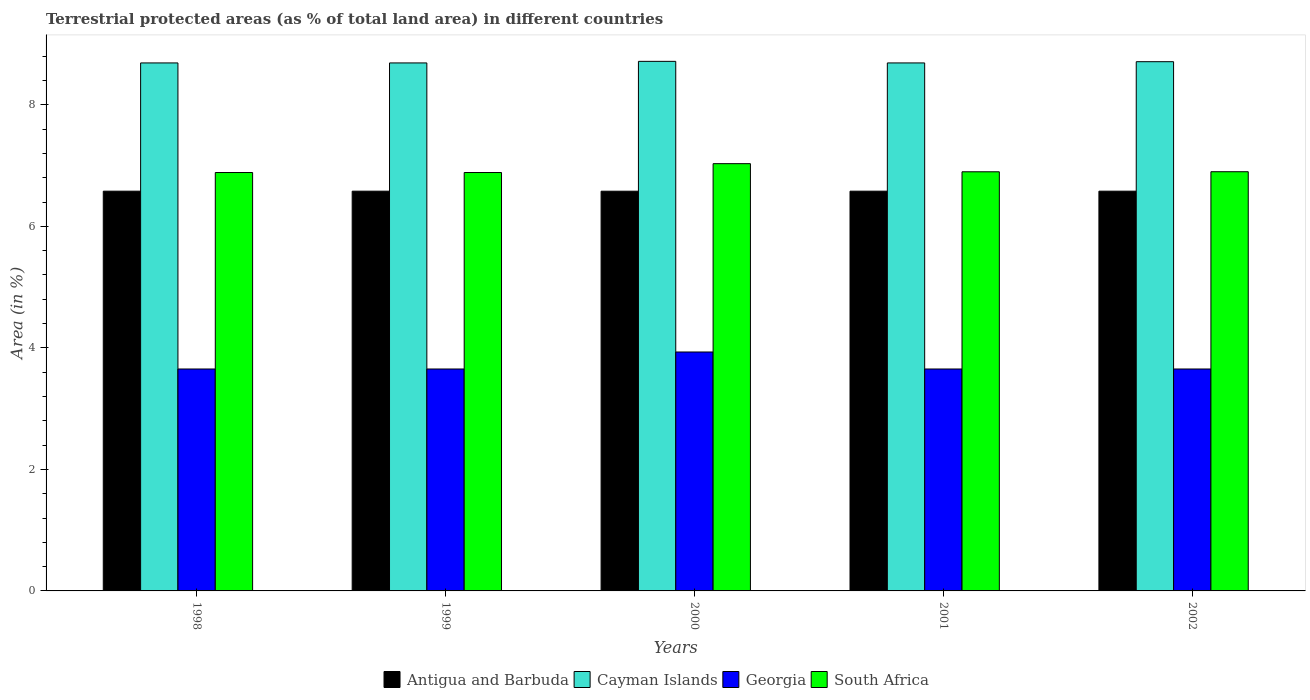How many different coloured bars are there?
Your response must be concise. 4. Are the number of bars per tick equal to the number of legend labels?
Your response must be concise. Yes. Are the number of bars on each tick of the X-axis equal?
Ensure brevity in your answer.  Yes. How many bars are there on the 3rd tick from the left?
Your answer should be compact. 4. How many bars are there on the 2nd tick from the right?
Give a very brief answer. 4. What is the label of the 3rd group of bars from the left?
Your answer should be very brief. 2000. In how many cases, is the number of bars for a given year not equal to the number of legend labels?
Your answer should be very brief. 0. What is the percentage of terrestrial protected land in South Africa in 2002?
Your response must be concise. 6.9. Across all years, what is the maximum percentage of terrestrial protected land in Georgia?
Offer a very short reply. 3.93. Across all years, what is the minimum percentage of terrestrial protected land in South Africa?
Offer a very short reply. 6.89. In which year was the percentage of terrestrial protected land in Antigua and Barbuda minimum?
Your response must be concise. 2000. What is the total percentage of terrestrial protected land in Antigua and Barbuda in the graph?
Provide a short and direct response. 32.9. What is the difference between the percentage of terrestrial protected land in Antigua and Barbuda in 1998 and that in 2002?
Provide a short and direct response. 0. What is the difference between the percentage of terrestrial protected land in Cayman Islands in 1998 and the percentage of terrestrial protected land in Georgia in 2001?
Your response must be concise. 5.04. What is the average percentage of terrestrial protected land in South Africa per year?
Ensure brevity in your answer.  6.92. In the year 2001, what is the difference between the percentage of terrestrial protected land in Antigua and Barbuda and percentage of terrestrial protected land in Georgia?
Your response must be concise. 2.93. In how many years, is the percentage of terrestrial protected land in Cayman Islands greater than 4 %?
Make the answer very short. 5. What is the ratio of the percentage of terrestrial protected land in South Africa in 2001 to that in 2002?
Your answer should be very brief. 1. Is the percentage of terrestrial protected land in South Africa in 1999 less than that in 2001?
Offer a very short reply. Yes. What is the difference between the highest and the second highest percentage of terrestrial protected land in Cayman Islands?
Make the answer very short. 0.01. What is the difference between the highest and the lowest percentage of terrestrial protected land in South Africa?
Make the answer very short. 0.15. In how many years, is the percentage of terrestrial protected land in Georgia greater than the average percentage of terrestrial protected land in Georgia taken over all years?
Keep it short and to the point. 1. Is the sum of the percentage of terrestrial protected land in Antigua and Barbuda in 1998 and 2000 greater than the maximum percentage of terrestrial protected land in Cayman Islands across all years?
Give a very brief answer. Yes. Is it the case that in every year, the sum of the percentage of terrestrial protected land in Cayman Islands and percentage of terrestrial protected land in South Africa is greater than the sum of percentage of terrestrial protected land in Antigua and Barbuda and percentage of terrestrial protected land in Georgia?
Provide a short and direct response. Yes. What does the 1st bar from the left in 1999 represents?
Make the answer very short. Antigua and Barbuda. What does the 1st bar from the right in 2000 represents?
Provide a short and direct response. South Africa. Is it the case that in every year, the sum of the percentage of terrestrial protected land in Georgia and percentage of terrestrial protected land in Antigua and Barbuda is greater than the percentage of terrestrial protected land in South Africa?
Your answer should be very brief. Yes. Are all the bars in the graph horizontal?
Ensure brevity in your answer.  No. How many years are there in the graph?
Provide a short and direct response. 5. What is the difference between two consecutive major ticks on the Y-axis?
Keep it short and to the point. 2. Are the values on the major ticks of Y-axis written in scientific E-notation?
Provide a short and direct response. No. How many legend labels are there?
Give a very brief answer. 4. What is the title of the graph?
Offer a very short reply. Terrestrial protected areas (as % of total land area) in different countries. Does "New Caledonia" appear as one of the legend labels in the graph?
Give a very brief answer. No. What is the label or title of the Y-axis?
Offer a very short reply. Area (in %). What is the Area (in %) in Antigua and Barbuda in 1998?
Offer a terse response. 6.58. What is the Area (in %) of Cayman Islands in 1998?
Keep it short and to the point. 8.69. What is the Area (in %) in Georgia in 1998?
Keep it short and to the point. 3.65. What is the Area (in %) in South Africa in 1998?
Your answer should be compact. 6.89. What is the Area (in %) in Antigua and Barbuda in 1999?
Your answer should be very brief. 6.58. What is the Area (in %) of Cayman Islands in 1999?
Provide a succinct answer. 8.69. What is the Area (in %) in Georgia in 1999?
Give a very brief answer. 3.65. What is the Area (in %) of South Africa in 1999?
Offer a terse response. 6.89. What is the Area (in %) of Antigua and Barbuda in 2000?
Provide a short and direct response. 6.58. What is the Area (in %) of Cayman Islands in 2000?
Ensure brevity in your answer.  8.72. What is the Area (in %) in Georgia in 2000?
Make the answer very short. 3.93. What is the Area (in %) of South Africa in 2000?
Your response must be concise. 7.03. What is the Area (in %) in Antigua and Barbuda in 2001?
Provide a succinct answer. 6.58. What is the Area (in %) of Cayman Islands in 2001?
Keep it short and to the point. 8.69. What is the Area (in %) of Georgia in 2001?
Keep it short and to the point. 3.65. What is the Area (in %) in South Africa in 2001?
Keep it short and to the point. 6.9. What is the Area (in %) in Antigua and Barbuda in 2002?
Keep it short and to the point. 6.58. What is the Area (in %) in Cayman Islands in 2002?
Your answer should be very brief. 8.71. What is the Area (in %) of Georgia in 2002?
Your response must be concise. 3.65. What is the Area (in %) in South Africa in 2002?
Your response must be concise. 6.9. Across all years, what is the maximum Area (in %) in Antigua and Barbuda?
Keep it short and to the point. 6.58. Across all years, what is the maximum Area (in %) in Cayman Islands?
Give a very brief answer. 8.72. Across all years, what is the maximum Area (in %) of Georgia?
Your response must be concise. 3.93. Across all years, what is the maximum Area (in %) in South Africa?
Your answer should be very brief. 7.03. Across all years, what is the minimum Area (in %) of Antigua and Barbuda?
Your answer should be compact. 6.58. Across all years, what is the minimum Area (in %) in Cayman Islands?
Offer a terse response. 8.69. Across all years, what is the minimum Area (in %) of Georgia?
Provide a short and direct response. 3.65. Across all years, what is the minimum Area (in %) of South Africa?
Give a very brief answer. 6.89. What is the total Area (in %) of Antigua and Barbuda in the graph?
Give a very brief answer. 32.9. What is the total Area (in %) in Cayman Islands in the graph?
Give a very brief answer. 43.5. What is the total Area (in %) in Georgia in the graph?
Offer a very short reply. 18.54. What is the total Area (in %) in South Africa in the graph?
Give a very brief answer. 34.6. What is the difference between the Area (in %) of Antigua and Barbuda in 1998 and that in 1999?
Offer a terse response. 0. What is the difference between the Area (in %) in Georgia in 1998 and that in 1999?
Provide a short and direct response. 0. What is the difference between the Area (in %) of Cayman Islands in 1998 and that in 2000?
Your answer should be compact. -0.03. What is the difference between the Area (in %) of Georgia in 1998 and that in 2000?
Keep it short and to the point. -0.28. What is the difference between the Area (in %) in South Africa in 1998 and that in 2000?
Make the answer very short. -0.15. What is the difference between the Area (in %) of Antigua and Barbuda in 1998 and that in 2001?
Offer a terse response. 0. What is the difference between the Area (in %) in Georgia in 1998 and that in 2001?
Provide a succinct answer. 0. What is the difference between the Area (in %) of South Africa in 1998 and that in 2001?
Make the answer very short. -0.01. What is the difference between the Area (in %) of Cayman Islands in 1998 and that in 2002?
Offer a terse response. -0.02. What is the difference between the Area (in %) of Georgia in 1998 and that in 2002?
Ensure brevity in your answer.  0. What is the difference between the Area (in %) in South Africa in 1998 and that in 2002?
Offer a terse response. -0.01. What is the difference between the Area (in %) in Antigua and Barbuda in 1999 and that in 2000?
Your answer should be compact. 0. What is the difference between the Area (in %) of Cayman Islands in 1999 and that in 2000?
Give a very brief answer. -0.03. What is the difference between the Area (in %) of Georgia in 1999 and that in 2000?
Ensure brevity in your answer.  -0.28. What is the difference between the Area (in %) of South Africa in 1999 and that in 2000?
Offer a very short reply. -0.15. What is the difference between the Area (in %) of Antigua and Barbuda in 1999 and that in 2001?
Ensure brevity in your answer.  0. What is the difference between the Area (in %) in Georgia in 1999 and that in 2001?
Your answer should be compact. 0. What is the difference between the Area (in %) of South Africa in 1999 and that in 2001?
Ensure brevity in your answer.  -0.01. What is the difference between the Area (in %) in Cayman Islands in 1999 and that in 2002?
Offer a very short reply. -0.02. What is the difference between the Area (in %) in South Africa in 1999 and that in 2002?
Offer a terse response. -0.01. What is the difference between the Area (in %) in Antigua and Barbuda in 2000 and that in 2001?
Ensure brevity in your answer.  -0. What is the difference between the Area (in %) in Cayman Islands in 2000 and that in 2001?
Provide a succinct answer. 0.03. What is the difference between the Area (in %) in Georgia in 2000 and that in 2001?
Offer a very short reply. 0.28. What is the difference between the Area (in %) in South Africa in 2000 and that in 2001?
Give a very brief answer. 0.13. What is the difference between the Area (in %) in Antigua and Barbuda in 2000 and that in 2002?
Keep it short and to the point. -0. What is the difference between the Area (in %) in Cayman Islands in 2000 and that in 2002?
Provide a succinct answer. 0.01. What is the difference between the Area (in %) in Georgia in 2000 and that in 2002?
Offer a very short reply. 0.28. What is the difference between the Area (in %) in South Africa in 2000 and that in 2002?
Ensure brevity in your answer.  0.13. What is the difference between the Area (in %) of Cayman Islands in 2001 and that in 2002?
Your answer should be compact. -0.02. What is the difference between the Area (in %) in Georgia in 2001 and that in 2002?
Offer a very short reply. 0. What is the difference between the Area (in %) of South Africa in 2001 and that in 2002?
Your answer should be compact. -0. What is the difference between the Area (in %) in Antigua and Barbuda in 1998 and the Area (in %) in Cayman Islands in 1999?
Your answer should be compact. -2.11. What is the difference between the Area (in %) in Antigua and Barbuda in 1998 and the Area (in %) in Georgia in 1999?
Provide a short and direct response. 2.93. What is the difference between the Area (in %) of Antigua and Barbuda in 1998 and the Area (in %) of South Africa in 1999?
Ensure brevity in your answer.  -0.31. What is the difference between the Area (in %) of Cayman Islands in 1998 and the Area (in %) of Georgia in 1999?
Ensure brevity in your answer.  5.04. What is the difference between the Area (in %) in Cayman Islands in 1998 and the Area (in %) in South Africa in 1999?
Your answer should be compact. 1.8. What is the difference between the Area (in %) in Georgia in 1998 and the Area (in %) in South Africa in 1999?
Your response must be concise. -3.23. What is the difference between the Area (in %) in Antigua and Barbuda in 1998 and the Area (in %) in Cayman Islands in 2000?
Your answer should be compact. -2.14. What is the difference between the Area (in %) in Antigua and Barbuda in 1998 and the Area (in %) in Georgia in 2000?
Offer a terse response. 2.65. What is the difference between the Area (in %) in Antigua and Barbuda in 1998 and the Area (in %) in South Africa in 2000?
Your response must be concise. -0.45. What is the difference between the Area (in %) in Cayman Islands in 1998 and the Area (in %) in Georgia in 2000?
Your response must be concise. 4.76. What is the difference between the Area (in %) of Cayman Islands in 1998 and the Area (in %) of South Africa in 2000?
Provide a short and direct response. 1.66. What is the difference between the Area (in %) in Georgia in 1998 and the Area (in %) in South Africa in 2000?
Provide a succinct answer. -3.38. What is the difference between the Area (in %) in Antigua and Barbuda in 1998 and the Area (in %) in Cayman Islands in 2001?
Make the answer very short. -2.11. What is the difference between the Area (in %) in Antigua and Barbuda in 1998 and the Area (in %) in Georgia in 2001?
Your response must be concise. 2.93. What is the difference between the Area (in %) in Antigua and Barbuda in 1998 and the Area (in %) in South Africa in 2001?
Ensure brevity in your answer.  -0.32. What is the difference between the Area (in %) in Cayman Islands in 1998 and the Area (in %) in Georgia in 2001?
Make the answer very short. 5.04. What is the difference between the Area (in %) in Cayman Islands in 1998 and the Area (in %) in South Africa in 2001?
Make the answer very short. 1.79. What is the difference between the Area (in %) of Georgia in 1998 and the Area (in %) of South Africa in 2001?
Give a very brief answer. -3.25. What is the difference between the Area (in %) of Antigua and Barbuda in 1998 and the Area (in %) of Cayman Islands in 2002?
Keep it short and to the point. -2.13. What is the difference between the Area (in %) of Antigua and Barbuda in 1998 and the Area (in %) of Georgia in 2002?
Your answer should be compact. 2.93. What is the difference between the Area (in %) of Antigua and Barbuda in 1998 and the Area (in %) of South Africa in 2002?
Ensure brevity in your answer.  -0.32. What is the difference between the Area (in %) in Cayman Islands in 1998 and the Area (in %) in Georgia in 2002?
Your answer should be compact. 5.04. What is the difference between the Area (in %) of Cayman Islands in 1998 and the Area (in %) of South Africa in 2002?
Your answer should be very brief. 1.79. What is the difference between the Area (in %) in Georgia in 1998 and the Area (in %) in South Africa in 2002?
Provide a succinct answer. -3.25. What is the difference between the Area (in %) of Antigua and Barbuda in 1999 and the Area (in %) of Cayman Islands in 2000?
Provide a short and direct response. -2.14. What is the difference between the Area (in %) in Antigua and Barbuda in 1999 and the Area (in %) in Georgia in 2000?
Your answer should be compact. 2.65. What is the difference between the Area (in %) in Antigua and Barbuda in 1999 and the Area (in %) in South Africa in 2000?
Offer a terse response. -0.45. What is the difference between the Area (in %) in Cayman Islands in 1999 and the Area (in %) in Georgia in 2000?
Your answer should be very brief. 4.76. What is the difference between the Area (in %) of Cayman Islands in 1999 and the Area (in %) of South Africa in 2000?
Give a very brief answer. 1.66. What is the difference between the Area (in %) in Georgia in 1999 and the Area (in %) in South Africa in 2000?
Give a very brief answer. -3.38. What is the difference between the Area (in %) in Antigua and Barbuda in 1999 and the Area (in %) in Cayman Islands in 2001?
Your response must be concise. -2.11. What is the difference between the Area (in %) in Antigua and Barbuda in 1999 and the Area (in %) in Georgia in 2001?
Keep it short and to the point. 2.93. What is the difference between the Area (in %) of Antigua and Barbuda in 1999 and the Area (in %) of South Africa in 2001?
Your answer should be compact. -0.32. What is the difference between the Area (in %) in Cayman Islands in 1999 and the Area (in %) in Georgia in 2001?
Offer a very short reply. 5.04. What is the difference between the Area (in %) in Cayman Islands in 1999 and the Area (in %) in South Africa in 2001?
Offer a very short reply. 1.79. What is the difference between the Area (in %) in Georgia in 1999 and the Area (in %) in South Africa in 2001?
Offer a terse response. -3.25. What is the difference between the Area (in %) of Antigua and Barbuda in 1999 and the Area (in %) of Cayman Islands in 2002?
Your answer should be very brief. -2.13. What is the difference between the Area (in %) of Antigua and Barbuda in 1999 and the Area (in %) of Georgia in 2002?
Your answer should be compact. 2.93. What is the difference between the Area (in %) in Antigua and Barbuda in 1999 and the Area (in %) in South Africa in 2002?
Make the answer very short. -0.32. What is the difference between the Area (in %) of Cayman Islands in 1999 and the Area (in %) of Georgia in 2002?
Ensure brevity in your answer.  5.04. What is the difference between the Area (in %) in Cayman Islands in 1999 and the Area (in %) in South Africa in 2002?
Keep it short and to the point. 1.79. What is the difference between the Area (in %) of Georgia in 1999 and the Area (in %) of South Africa in 2002?
Offer a terse response. -3.25. What is the difference between the Area (in %) of Antigua and Barbuda in 2000 and the Area (in %) of Cayman Islands in 2001?
Give a very brief answer. -2.11. What is the difference between the Area (in %) in Antigua and Barbuda in 2000 and the Area (in %) in Georgia in 2001?
Your response must be concise. 2.93. What is the difference between the Area (in %) of Antigua and Barbuda in 2000 and the Area (in %) of South Africa in 2001?
Your response must be concise. -0.32. What is the difference between the Area (in %) of Cayman Islands in 2000 and the Area (in %) of Georgia in 2001?
Offer a terse response. 5.06. What is the difference between the Area (in %) of Cayman Islands in 2000 and the Area (in %) of South Africa in 2001?
Offer a terse response. 1.82. What is the difference between the Area (in %) of Georgia in 2000 and the Area (in %) of South Africa in 2001?
Offer a very short reply. -2.97. What is the difference between the Area (in %) of Antigua and Barbuda in 2000 and the Area (in %) of Cayman Islands in 2002?
Offer a terse response. -2.13. What is the difference between the Area (in %) of Antigua and Barbuda in 2000 and the Area (in %) of Georgia in 2002?
Make the answer very short. 2.93. What is the difference between the Area (in %) in Antigua and Barbuda in 2000 and the Area (in %) in South Africa in 2002?
Ensure brevity in your answer.  -0.32. What is the difference between the Area (in %) in Cayman Islands in 2000 and the Area (in %) in Georgia in 2002?
Offer a very short reply. 5.06. What is the difference between the Area (in %) of Cayman Islands in 2000 and the Area (in %) of South Africa in 2002?
Offer a terse response. 1.82. What is the difference between the Area (in %) in Georgia in 2000 and the Area (in %) in South Africa in 2002?
Provide a succinct answer. -2.97. What is the difference between the Area (in %) in Antigua and Barbuda in 2001 and the Area (in %) in Cayman Islands in 2002?
Your response must be concise. -2.13. What is the difference between the Area (in %) of Antigua and Barbuda in 2001 and the Area (in %) of Georgia in 2002?
Keep it short and to the point. 2.93. What is the difference between the Area (in %) in Antigua and Barbuda in 2001 and the Area (in %) in South Africa in 2002?
Keep it short and to the point. -0.32. What is the difference between the Area (in %) of Cayman Islands in 2001 and the Area (in %) of Georgia in 2002?
Offer a terse response. 5.04. What is the difference between the Area (in %) in Cayman Islands in 2001 and the Area (in %) in South Africa in 2002?
Make the answer very short. 1.79. What is the difference between the Area (in %) of Georgia in 2001 and the Area (in %) of South Africa in 2002?
Offer a terse response. -3.25. What is the average Area (in %) of Antigua and Barbuda per year?
Make the answer very short. 6.58. What is the average Area (in %) of Cayman Islands per year?
Provide a succinct answer. 8.7. What is the average Area (in %) of Georgia per year?
Give a very brief answer. 3.71. What is the average Area (in %) of South Africa per year?
Your answer should be compact. 6.92. In the year 1998, what is the difference between the Area (in %) in Antigua and Barbuda and Area (in %) in Cayman Islands?
Offer a terse response. -2.11. In the year 1998, what is the difference between the Area (in %) of Antigua and Barbuda and Area (in %) of Georgia?
Your response must be concise. 2.93. In the year 1998, what is the difference between the Area (in %) in Antigua and Barbuda and Area (in %) in South Africa?
Your answer should be very brief. -0.31. In the year 1998, what is the difference between the Area (in %) in Cayman Islands and Area (in %) in Georgia?
Ensure brevity in your answer.  5.04. In the year 1998, what is the difference between the Area (in %) of Cayman Islands and Area (in %) of South Africa?
Keep it short and to the point. 1.8. In the year 1998, what is the difference between the Area (in %) in Georgia and Area (in %) in South Africa?
Provide a short and direct response. -3.23. In the year 1999, what is the difference between the Area (in %) in Antigua and Barbuda and Area (in %) in Cayman Islands?
Your answer should be compact. -2.11. In the year 1999, what is the difference between the Area (in %) in Antigua and Barbuda and Area (in %) in Georgia?
Give a very brief answer. 2.93. In the year 1999, what is the difference between the Area (in %) of Antigua and Barbuda and Area (in %) of South Africa?
Your answer should be compact. -0.31. In the year 1999, what is the difference between the Area (in %) in Cayman Islands and Area (in %) in Georgia?
Offer a terse response. 5.04. In the year 1999, what is the difference between the Area (in %) of Cayman Islands and Area (in %) of South Africa?
Your response must be concise. 1.8. In the year 1999, what is the difference between the Area (in %) in Georgia and Area (in %) in South Africa?
Your answer should be very brief. -3.23. In the year 2000, what is the difference between the Area (in %) in Antigua and Barbuda and Area (in %) in Cayman Islands?
Provide a short and direct response. -2.14. In the year 2000, what is the difference between the Area (in %) in Antigua and Barbuda and Area (in %) in Georgia?
Make the answer very short. 2.65. In the year 2000, what is the difference between the Area (in %) of Antigua and Barbuda and Area (in %) of South Africa?
Your answer should be compact. -0.45. In the year 2000, what is the difference between the Area (in %) of Cayman Islands and Area (in %) of Georgia?
Provide a short and direct response. 4.78. In the year 2000, what is the difference between the Area (in %) of Cayman Islands and Area (in %) of South Africa?
Ensure brevity in your answer.  1.68. In the year 2000, what is the difference between the Area (in %) in Georgia and Area (in %) in South Africa?
Your response must be concise. -3.1. In the year 2001, what is the difference between the Area (in %) in Antigua and Barbuda and Area (in %) in Cayman Islands?
Make the answer very short. -2.11. In the year 2001, what is the difference between the Area (in %) in Antigua and Barbuda and Area (in %) in Georgia?
Provide a succinct answer. 2.93. In the year 2001, what is the difference between the Area (in %) of Antigua and Barbuda and Area (in %) of South Africa?
Your response must be concise. -0.32. In the year 2001, what is the difference between the Area (in %) in Cayman Islands and Area (in %) in Georgia?
Keep it short and to the point. 5.04. In the year 2001, what is the difference between the Area (in %) of Cayman Islands and Area (in %) of South Africa?
Your answer should be very brief. 1.79. In the year 2001, what is the difference between the Area (in %) of Georgia and Area (in %) of South Africa?
Make the answer very short. -3.25. In the year 2002, what is the difference between the Area (in %) in Antigua and Barbuda and Area (in %) in Cayman Islands?
Your response must be concise. -2.13. In the year 2002, what is the difference between the Area (in %) of Antigua and Barbuda and Area (in %) of Georgia?
Provide a short and direct response. 2.93. In the year 2002, what is the difference between the Area (in %) in Antigua and Barbuda and Area (in %) in South Africa?
Your answer should be compact. -0.32. In the year 2002, what is the difference between the Area (in %) of Cayman Islands and Area (in %) of Georgia?
Keep it short and to the point. 5.06. In the year 2002, what is the difference between the Area (in %) in Cayman Islands and Area (in %) in South Africa?
Keep it short and to the point. 1.81. In the year 2002, what is the difference between the Area (in %) in Georgia and Area (in %) in South Africa?
Your response must be concise. -3.25. What is the ratio of the Area (in %) of Antigua and Barbuda in 1998 to that in 1999?
Keep it short and to the point. 1. What is the ratio of the Area (in %) of Cayman Islands in 1998 to that in 1999?
Your response must be concise. 1. What is the ratio of the Area (in %) of Antigua and Barbuda in 1998 to that in 2000?
Provide a succinct answer. 1. What is the ratio of the Area (in %) in Cayman Islands in 1998 to that in 2000?
Offer a very short reply. 1. What is the ratio of the Area (in %) in Georgia in 1998 to that in 2000?
Your response must be concise. 0.93. What is the ratio of the Area (in %) of South Africa in 1998 to that in 2000?
Provide a short and direct response. 0.98. What is the ratio of the Area (in %) in Antigua and Barbuda in 1998 to that in 2002?
Your answer should be compact. 1. What is the ratio of the Area (in %) of Cayman Islands in 1998 to that in 2002?
Ensure brevity in your answer.  1. What is the ratio of the Area (in %) in Georgia in 1999 to that in 2000?
Provide a succinct answer. 0.93. What is the ratio of the Area (in %) in South Africa in 1999 to that in 2000?
Your answer should be compact. 0.98. What is the ratio of the Area (in %) of Georgia in 1999 to that in 2001?
Keep it short and to the point. 1. What is the ratio of the Area (in %) in South Africa in 1999 to that in 2001?
Give a very brief answer. 1. What is the ratio of the Area (in %) in Antigua and Barbuda in 1999 to that in 2002?
Keep it short and to the point. 1. What is the ratio of the Area (in %) of Georgia in 1999 to that in 2002?
Provide a succinct answer. 1. What is the ratio of the Area (in %) of South Africa in 1999 to that in 2002?
Provide a succinct answer. 1. What is the ratio of the Area (in %) of Antigua and Barbuda in 2000 to that in 2001?
Provide a succinct answer. 1. What is the ratio of the Area (in %) in Cayman Islands in 2000 to that in 2001?
Your answer should be very brief. 1. What is the ratio of the Area (in %) of Georgia in 2000 to that in 2001?
Give a very brief answer. 1.08. What is the ratio of the Area (in %) in South Africa in 2000 to that in 2001?
Ensure brevity in your answer.  1.02. What is the ratio of the Area (in %) of Georgia in 2000 to that in 2002?
Make the answer very short. 1.08. What is the ratio of the Area (in %) of South Africa in 2000 to that in 2002?
Keep it short and to the point. 1.02. What is the ratio of the Area (in %) of Georgia in 2001 to that in 2002?
Keep it short and to the point. 1. What is the difference between the highest and the second highest Area (in %) in Antigua and Barbuda?
Provide a succinct answer. 0. What is the difference between the highest and the second highest Area (in %) of Cayman Islands?
Provide a short and direct response. 0.01. What is the difference between the highest and the second highest Area (in %) in Georgia?
Give a very brief answer. 0.28. What is the difference between the highest and the second highest Area (in %) in South Africa?
Keep it short and to the point. 0.13. What is the difference between the highest and the lowest Area (in %) in Antigua and Barbuda?
Keep it short and to the point. 0. What is the difference between the highest and the lowest Area (in %) in Cayman Islands?
Your answer should be very brief. 0.03. What is the difference between the highest and the lowest Area (in %) in Georgia?
Make the answer very short. 0.28. What is the difference between the highest and the lowest Area (in %) in South Africa?
Provide a succinct answer. 0.15. 